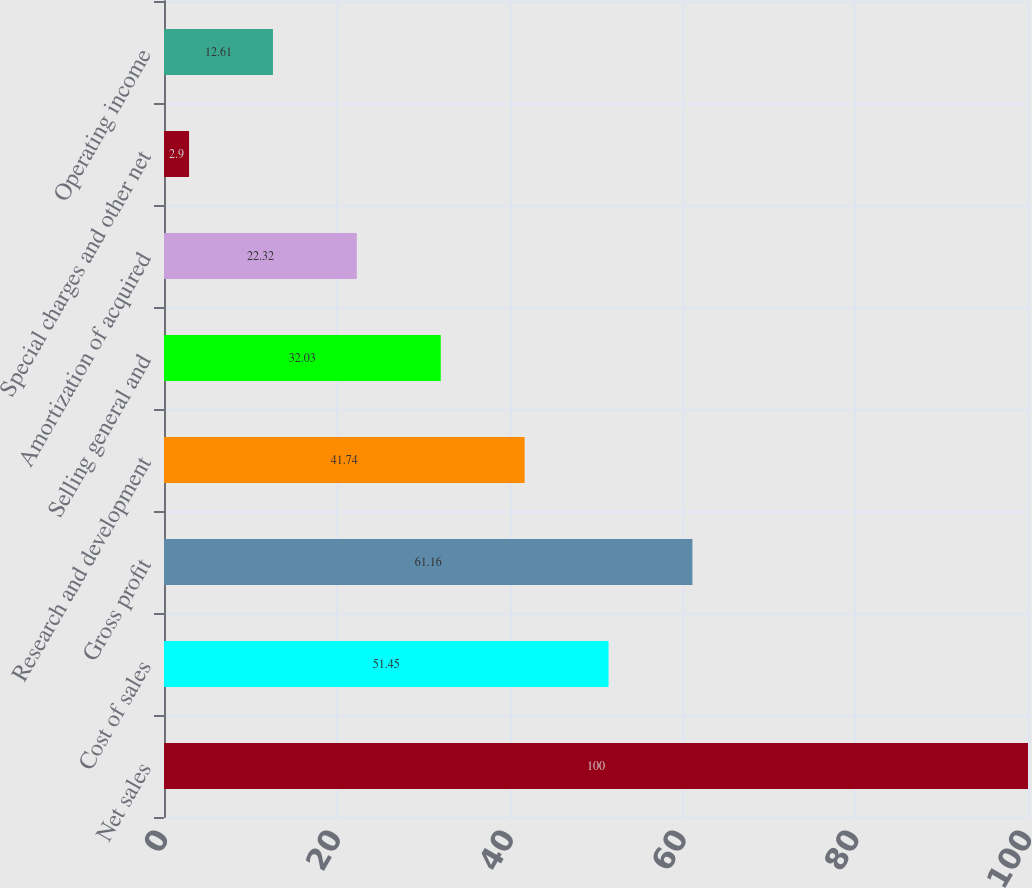Convert chart. <chart><loc_0><loc_0><loc_500><loc_500><bar_chart><fcel>Net sales<fcel>Cost of sales<fcel>Gross profit<fcel>Research and development<fcel>Selling general and<fcel>Amortization of acquired<fcel>Special charges and other net<fcel>Operating income<nl><fcel>100<fcel>51.45<fcel>61.16<fcel>41.74<fcel>32.03<fcel>22.32<fcel>2.9<fcel>12.61<nl></chart> 